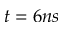<formula> <loc_0><loc_0><loc_500><loc_500>t = 6 n s</formula> 